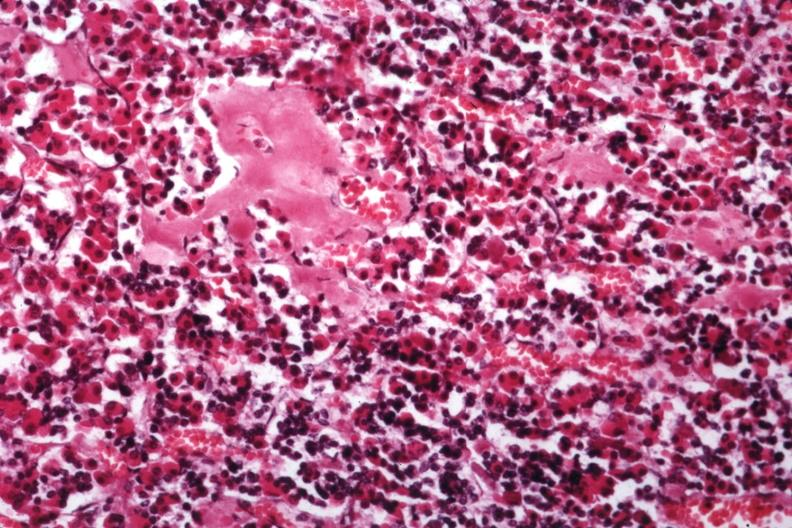what is present?
Answer the question using a single word or phrase. Amyloidosis 